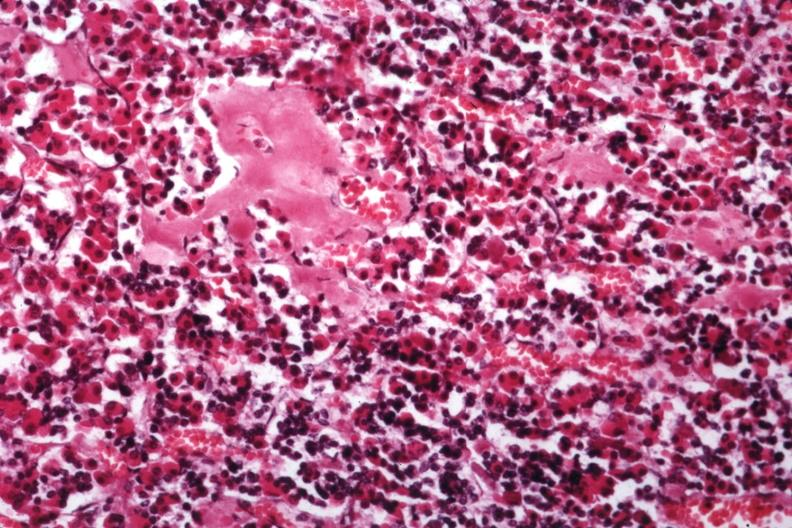what is present?
Answer the question using a single word or phrase. Amyloidosis 